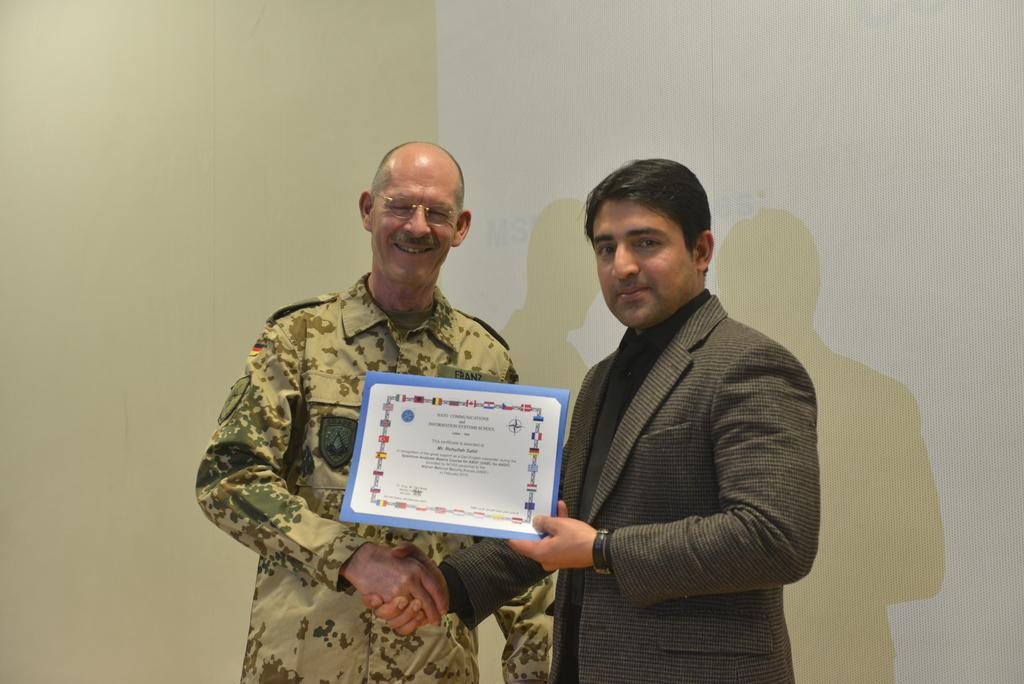How many people are in the image? There are two men in the image. What is the second person doing in the image? The second person is presenting an award and giving a handshake to the first person. What can be seen in the background of the image? There is a wall in the background of the image. What type of advice is the first person giving to the second person in the image? There is no indication in the image that the first person is giving advice to the second person. 